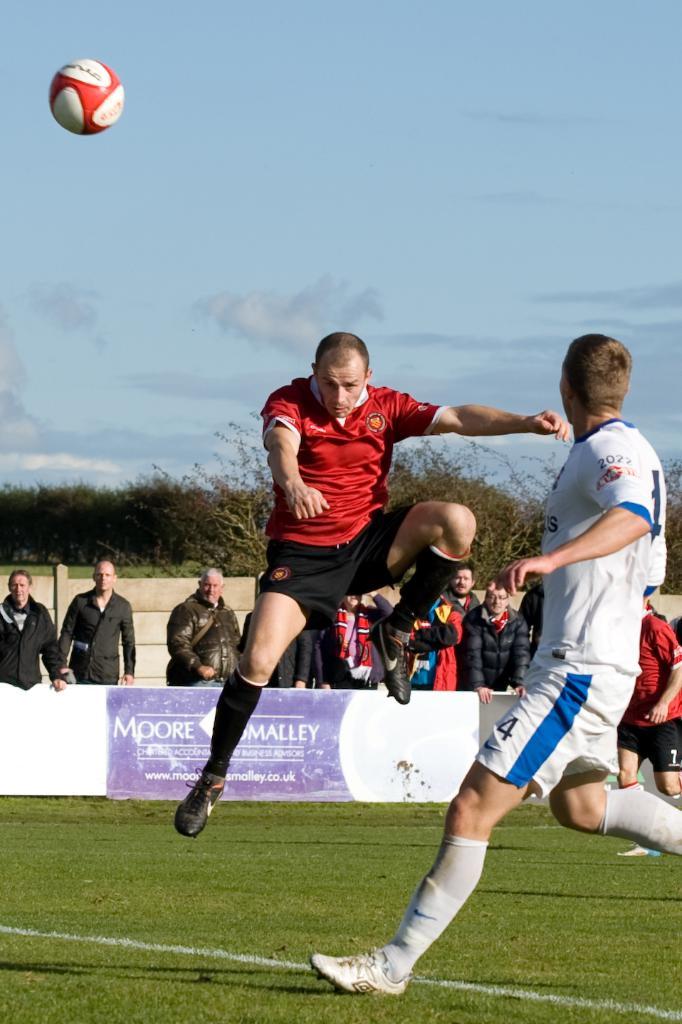What name is on the ad?
Give a very brief answer. Moore. 